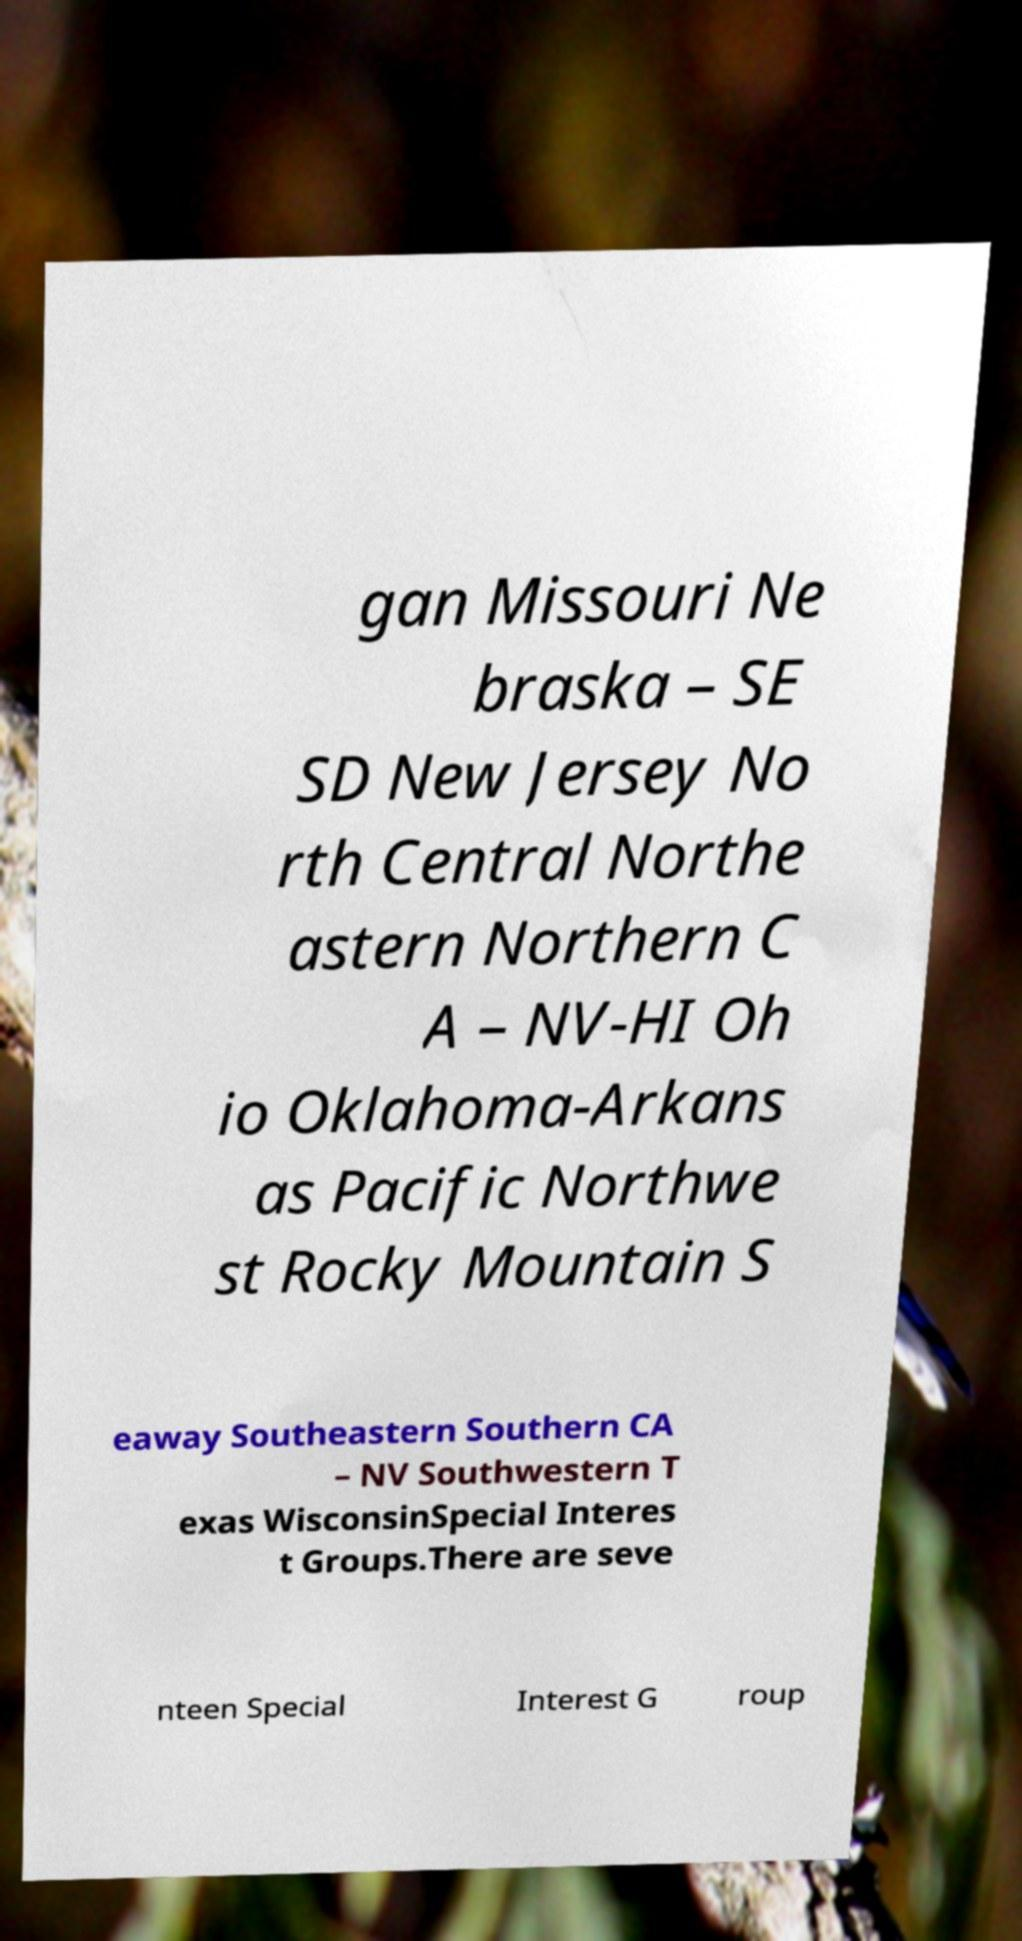Could you assist in decoding the text presented in this image and type it out clearly? gan Missouri Ne braska – SE SD New Jersey No rth Central Northe astern Northern C A – NV-HI Oh io Oklahoma-Arkans as Pacific Northwe st Rocky Mountain S eaway Southeastern Southern CA – NV Southwestern T exas WisconsinSpecial Interes t Groups.There are seve nteen Special Interest G roup 